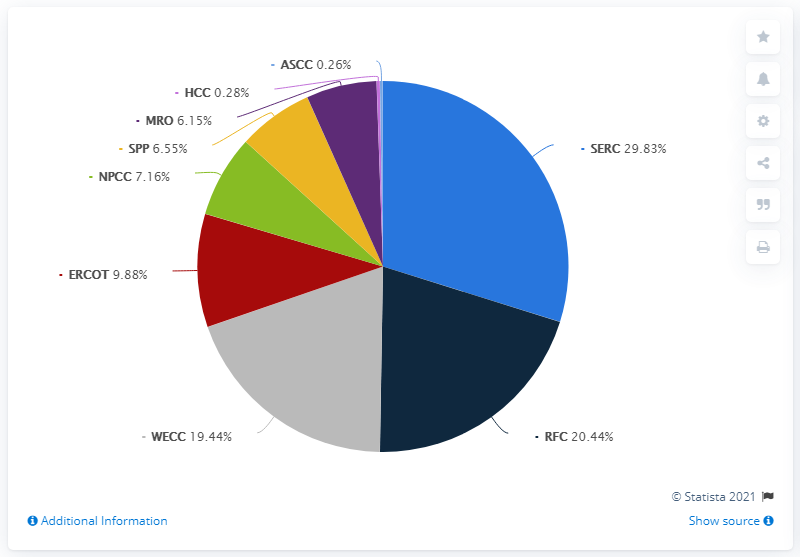Identify some key points in this picture. The Southeastern Electric Reliability Council is responsible for approximately 29.83% of the country's electricity generation capacity. 